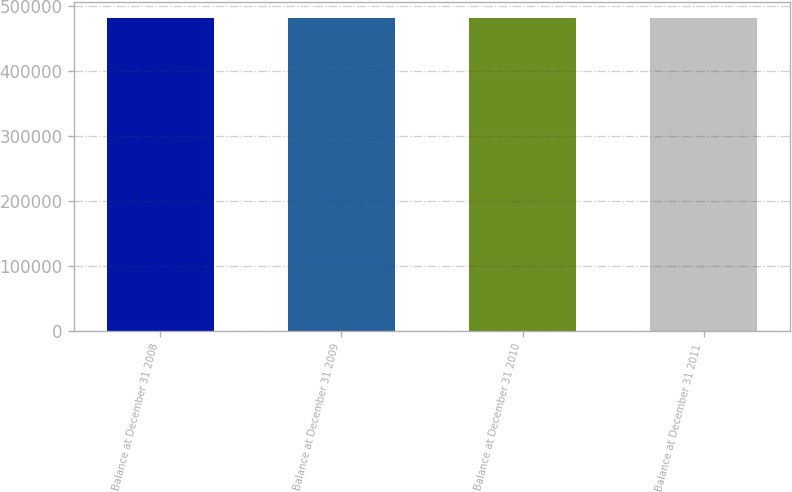<chart> <loc_0><loc_0><loc_500><loc_500><bar_chart><fcel>Balance at December 31 2008<fcel>Balance at December 31 2009<fcel>Balance at December 31 2010<fcel>Balance at December 31 2011<nl><fcel>481994<fcel>481994<fcel>481994<fcel>481994<nl></chart> 